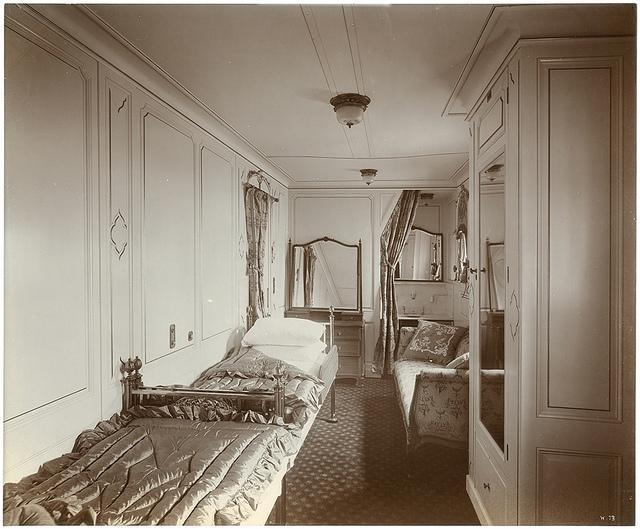How many beds are in this room?
Give a very brief answer. 3. How many beds can you see?
Give a very brief answer. 2. How many of the zebras are standing up?
Give a very brief answer. 0. 